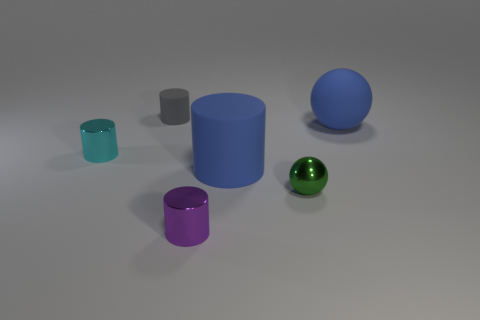Is the size of the green shiny ball the same as the matte cylinder that is right of the small purple metal object?
Provide a succinct answer. No. How many objects are either tiny cyan shiny cylinders or shiny things?
Your answer should be compact. 3. Is there a green ball that has the same material as the purple cylinder?
Offer a terse response. Yes. There is a ball that is the same color as the big cylinder; what is its size?
Give a very brief answer. Large. There is a shiny object that is on the right side of the shiny cylinder in front of the tiny sphere; what color is it?
Keep it short and to the point. Green. Does the cyan metallic cylinder have the same size as the blue cylinder?
Give a very brief answer. No. What number of cylinders are tiny purple metal things or large blue rubber things?
Your response must be concise. 2. What number of blue spheres are on the left side of the big object that is in front of the blue rubber ball?
Offer a terse response. 0. Is the shape of the small gray object the same as the cyan metal thing?
Ensure brevity in your answer.  Yes. What size is the other rubber object that is the same shape as the tiny gray object?
Provide a succinct answer. Large. 